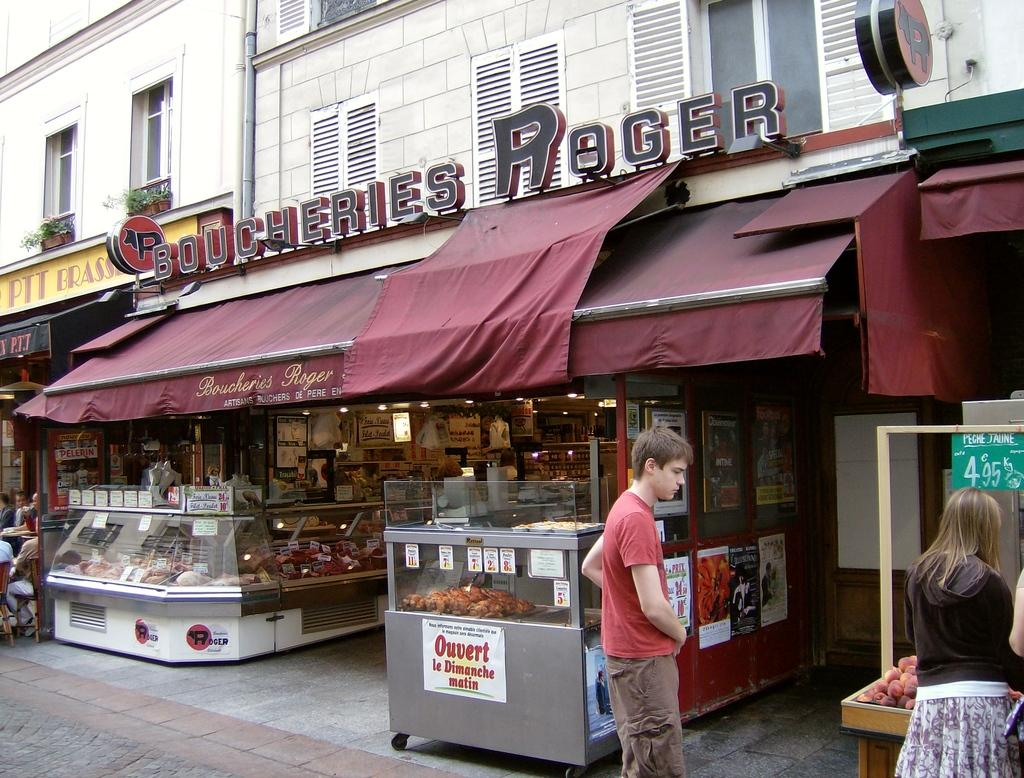<image>
Present a compact description of the photo's key features. the outside of a business that is labeled as 'boucheries roger' on the top 